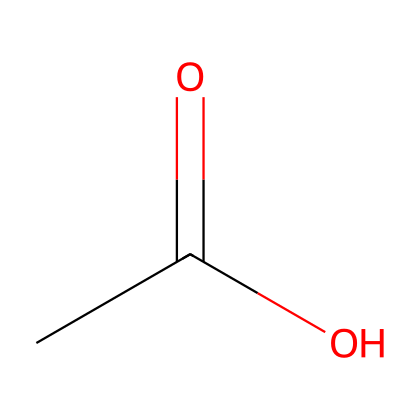What is the name of this chemical? The SMILES representation CC(=O)O represents acetic acid, which is commonly found in vinegar. This name is derived from the functional group present in the structure, which indicates it is a carboxylic acid.
Answer: acetic acid How many carbon atoms are in acetic acid? The structure CC(=O)O consists of two carbon atoms. The "C" at the start indicates one carbon atom, while the "=O" portion indicates a carbon atom with a double bond to an oxygen atom and is counted as part of the same molecule.
Answer: two What functional group is present in acetic acid? The SMILES representation CC(=O)O shows a carboxyl group (-COOH), which is identified by the presence of a carbon double bonded to an oxygen and also bonded to a hydroxyl group (-OH). This characteristic is what defines acids like acetic acid.
Answer: carboxyl group How many hydrogen atoms are in acetic acid? In the molecular structure represented by CC(=O)O, there are four hydrogen atoms associated with the two carbon atoms and the carboxyl group. The first carbon (CH3) contributes three hydrogen atoms, while the carboxyl group contributes one.
Answer: four Is acetic acid a strong or weak acid? Acetic acid does not completely dissociate in solution, meaning it is classified as a weak acid. The structure implies partial ionization, typical of organic acids like acetic acid, which release protons to some extent but not fully.
Answer: weak acid What type of bonding is present between the carbon and oxygen in the carboxyl group? The bonding between the carbon and oxygen in the carboxyl group is both a single bond (C-O in the hydroxyl) and a double bond (C=O). This hybridization of bonds contributes to the acidic properties of the molecule.
Answer: double bond and single bond 